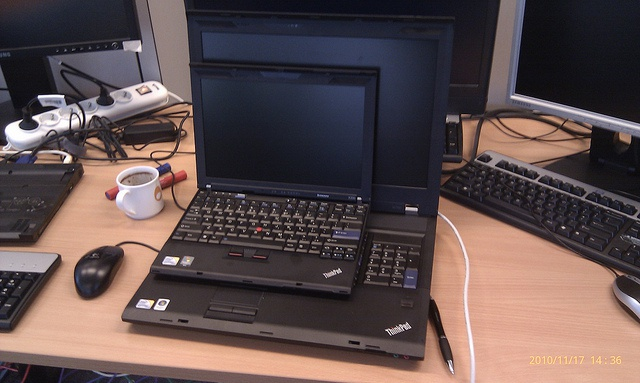Describe the objects in this image and their specific colors. I can see laptop in black, navy, and gray tones, laptop in black and gray tones, tv in black, gray, and darkgray tones, tv in black, gray, and darkgray tones, and keyboard in black and gray tones in this image. 